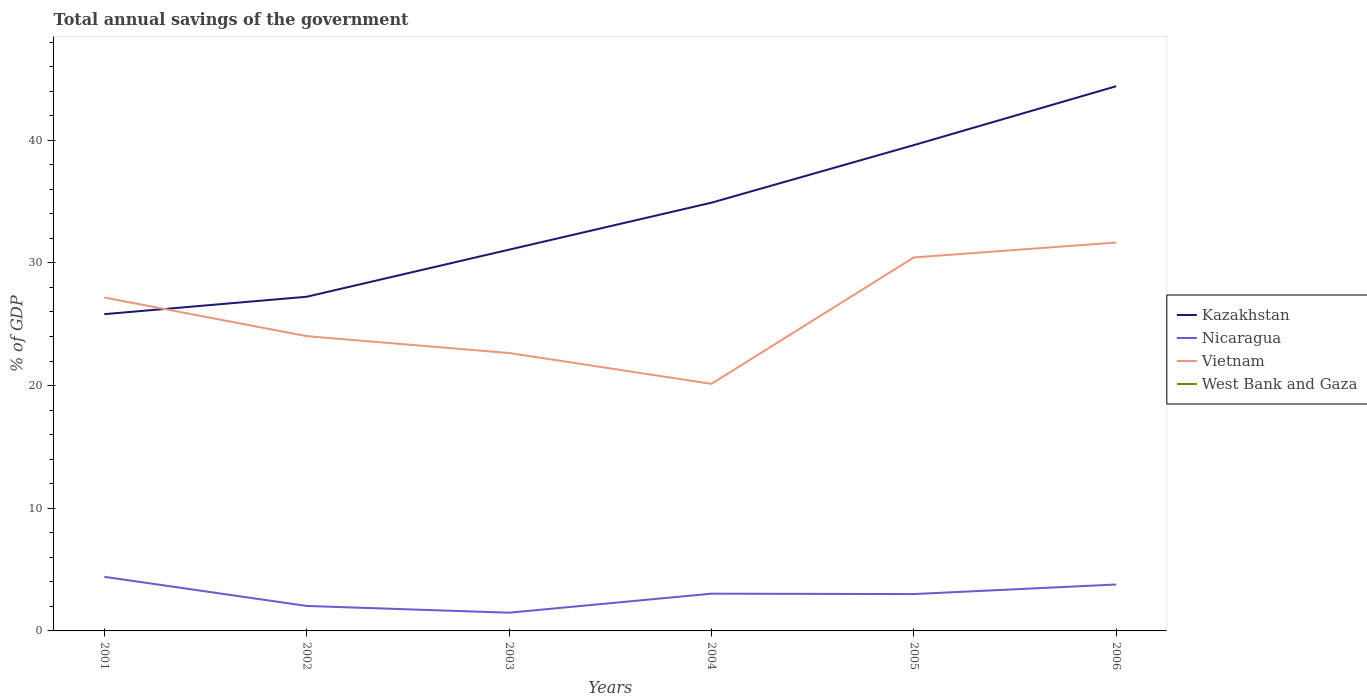Does the line corresponding to Nicaragua intersect with the line corresponding to Kazakhstan?
Provide a succinct answer. No. Is the number of lines equal to the number of legend labels?
Your answer should be very brief. No. Across all years, what is the maximum total annual savings of the government in Nicaragua?
Keep it short and to the point. 1.49. What is the total total annual savings of the government in Nicaragua in the graph?
Offer a very short reply. 0.55. What is the difference between the highest and the second highest total annual savings of the government in Nicaragua?
Your answer should be very brief. 2.93. What is the difference between the highest and the lowest total annual savings of the government in Vietnam?
Your answer should be very brief. 3. Is the total annual savings of the government in West Bank and Gaza strictly greater than the total annual savings of the government in Kazakhstan over the years?
Keep it short and to the point. Yes. How many lines are there?
Make the answer very short. 3. How many years are there in the graph?
Your answer should be very brief. 6. Does the graph contain grids?
Offer a very short reply. No. Where does the legend appear in the graph?
Make the answer very short. Center right. How many legend labels are there?
Provide a short and direct response. 4. How are the legend labels stacked?
Ensure brevity in your answer.  Vertical. What is the title of the graph?
Your response must be concise. Total annual savings of the government. Does "Korea (Republic)" appear as one of the legend labels in the graph?
Make the answer very short. No. What is the label or title of the Y-axis?
Keep it short and to the point. % of GDP. What is the % of GDP of Kazakhstan in 2001?
Offer a very short reply. 25.82. What is the % of GDP in Nicaragua in 2001?
Provide a succinct answer. 4.41. What is the % of GDP of Vietnam in 2001?
Keep it short and to the point. 27.17. What is the % of GDP of Kazakhstan in 2002?
Offer a very short reply. 27.24. What is the % of GDP of Nicaragua in 2002?
Provide a succinct answer. 2.04. What is the % of GDP in Vietnam in 2002?
Your response must be concise. 24.03. What is the % of GDP of Kazakhstan in 2003?
Provide a short and direct response. 31.07. What is the % of GDP in Nicaragua in 2003?
Provide a short and direct response. 1.49. What is the % of GDP of Vietnam in 2003?
Provide a short and direct response. 22.65. What is the % of GDP of West Bank and Gaza in 2003?
Provide a succinct answer. 0. What is the % of GDP in Kazakhstan in 2004?
Ensure brevity in your answer.  34.9. What is the % of GDP in Nicaragua in 2004?
Ensure brevity in your answer.  3.04. What is the % of GDP of Vietnam in 2004?
Ensure brevity in your answer.  20.14. What is the % of GDP in West Bank and Gaza in 2004?
Offer a very short reply. 0. What is the % of GDP in Kazakhstan in 2005?
Give a very brief answer. 39.6. What is the % of GDP of Nicaragua in 2005?
Provide a succinct answer. 3. What is the % of GDP of Vietnam in 2005?
Your response must be concise. 30.44. What is the % of GDP in West Bank and Gaza in 2005?
Provide a short and direct response. 0. What is the % of GDP in Kazakhstan in 2006?
Provide a succinct answer. 44.4. What is the % of GDP in Nicaragua in 2006?
Your response must be concise. 3.78. What is the % of GDP of Vietnam in 2006?
Provide a succinct answer. 31.66. Across all years, what is the maximum % of GDP in Kazakhstan?
Provide a succinct answer. 44.4. Across all years, what is the maximum % of GDP of Nicaragua?
Your answer should be very brief. 4.41. Across all years, what is the maximum % of GDP in Vietnam?
Ensure brevity in your answer.  31.66. Across all years, what is the minimum % of GDP in Kazakhstan?
Keep it short and to the point. 25.82. Across all years, what is the minimum % of GDP in Nicaragua?
Provide a short and direct response. 1.49. Across all years, what is the minimum % of GDP in Vietnam?
Your answer should be compact. 20.14. What is the total % of GDP in Kazakhstan in the graph?
Offer a terse response. 203.03. What is the total % of GDP of Nicaragua in the graph?
Provide a short and direct response. 17.75. What is the total % of GDP in Vietnam in the graph?
Ensure brevity in your answer.  156.09. What is the difference between the % of GDP in Kazakhstan in 2001 and that in 2002?
Your answer should be compact. -1.42. What is the difference between the % of GDP in Nicaragua in 2001 and that in 2002?
Ensure brevity in your answer.  2.38. What is the difference between the % of GDP in Vietnam in 2001 and that in 2002?
Offer a terse response. 3.15. What is the difference between the % of GDP in Kazakhstan in 2001 and that in 2003?
Your answer should be very brief. -5.26. What is the difference between the % of GDP in Nicaragua in 2001 and that in 2003?
Provide a succinct answer. 2.93. What is the difference between the % of GDP in Vietnam in 2001 and that in 2003?
Provide a succinct answer. 4.52. What is the difference between the % of GDP in Kazakhstan in 2001 and that in 2004?
Your answer should be compact. -9.09. What is the difference between the % of GDP of Nicaragua in 2001 and that in 2004?
Keep it short and to the point. 1.38. What is the difference between the % of GDP in Vietnam in 2001 and that in 2004?
Offer a terse response. 7.03. What is the difference between the % of GDP in Kazakhstan in 2001 and that in 2005?
Offer a very short reply. -13.78. What is the difference between the % of GDP in Nicaragua in 2001 and that in 2005?
Provide a short and direct response. 1.41. What is the difference between the % of GDP of Vietnam in 2001 and that in 2005?
Your answer should be very brief. -3.27. What is the difference between the % of GDP of Kazakhstan in 2001 and that in 2006?
Your response must be concise. -18.58. What is the difference between the % of GDP in Nicaragua in 2001 and that in 2006?
Your response must be concise. 0.63. What is the difference between the % of GDP in Vietnam in 2001 and that in 2006?
Your answer should be very brief. -4.48. What is the difference between the % of GDP in Kazakhstan in 2002 and that in 2003?
Offer a very short reply. -3.84. What is the difference between the % of GDP of Nicaragua in 2002 and that in 2003?
Make the answer very short. 0.55. What is the difference between the % of GDP in Vietnam in 2002 and that in 2003?
Your answer should be very brief. 1.37. What is the difference between the % of GDP of Kazakhstan in 2002 and that in 2004?
Provide a succinct answer. -7.67. What is the difference between the % of GDP of Nicaragua in 2002 and that in 2004?
Keep it short and to the point. -1. What is the difference between the % of GDP of Vietnam in 2002 and that in 2004?
Offer a very short reply. 3.89. What is the difference between the % of GDP of Kazakhstan in 2002 and that in 2005?
Ensure brevity in your answer.  -12.36. What is the difference between the % of GDP of Nicaragua in 2002 and that in 2005?
Provide a short and direct response. -0.97. What is the difference between the % of GDP in Vietnam in 2002 and that in 2005?
Keep it short and to the point. -6.42. What is the difference between the % of GDP in Kazakhstan in 2002 and that in 2006?
Ensure brevity in your answer.  -17.16. What is the difference between the % of GDP of Nicaragua in 2002 and that in 2006?
Offer a terse response. -1.75. What is the difference between the % of GDP of Vietnam in 2002 and that in 2006?
Keep it short and to the point. -7.63. What is the difference between the % of GDP of Kazakhstan in 2003 and that in 2004?
Provide a succinct answer. -3.83. What is the difference between the % of GDP in Nicaragua in 2003 and that in 2004?
Your response must be concise. -1.55. What is the difference between the % of GDP of Vietnam in 2003 and that in 2004?
Provide a succinct answer. 2.51. What is the difference between the % of GDP in Kazakhstan in 2003 and that in 2005?
Provide a short and direct response. -8.52. What is the difference between the % of GDP in Nicaragua in 2003 and that in 2005?
Your answer should be very brief. -1.52. What is the difference between the % of GDP in Vietnam in 2003 and that in 2005?
Provide a succinct answer. -7.79. What is the difference between the % of GDP of Kazakhstan in 2003 and that in 2006?
Ensure brevity in your answer.  -13.32. What is the difference between the % of GDP of Nicaragua in 2003 and that in 2006?
Your answer should be compact. -2.3. What is the difference between the % of GDP in Vietnam in 2003 and that in 2006?
Ensure brevity in your answer.  -9.01. What is the difference between the % of GDP of Kazakhstan in 2004 and that in 2005?
Your answer should be very brief. -4.69. What is the difference between the % of GDP of Nicaragua in 2004 and that in 2005?
Ensure brevity in your answer.  0.03. What is the difference between the % of GDP of Vietnam in 2004 and that in 2005?
Offer a very short reply. -10.3. What is the difference between the % of GDP of Kazakhstan in 2004 and that in 2006?
Offer a terse response. -9.5. What is the difference between the % of GDP in Nicaragua in 2004 and that in 2006?
Your answer should be very brief. -0.75. What is the difference between the % of GDP of Vietnam in 2004 and that in 2006?
Offer a very short reply. -11.52. What is the difference between the % of GDP in Kazakhstan in 2005 and that in 2006?
Provide a succinct answer. -4.8. What is the difference between the % of GDP in Nicaragua in 2005 and that in 2006?
Provide a succinct answer. -0.78. What is the difference between the % of GDP of Vietnam in 2005 and that in 2006?
Give a very brief answer. -1.22. What is the difference between the % of GDP in Kazakhstan in 2001 and the % of GDP in Nicaragua in 2002?
Offer a very short reply. 23.78. What is the difference between the % of GDP of Kazakhstan in 2001 and the % of GDP of Vietnam in 2002?
Your response must be concise. 1.79. What is the difference between the % of GDP in Nicaragua in 2001 and the % of GDP in Vietnam in 2002?
Offer a terse response. -19.62. What is the difference between the % of GDP of Kazakhstan in 2001 and the % of GDP of Nicaragua in 2003?
Your answer should be very brief. 24.33. What is the difference between the % of GDP in Kazakhstan in 2001 and the % of GDP in Vietnam in 2003?
Provide a short and direct response. 3.17. What is the difference between the % of GDP in Nicaragua in 2001 and the % of GDP in Vietnam in 2003?
Your response must be concise. -18.24. What is the difference between the % of GDP in Kazakhstan in 2001 and the % of GDP in Nicaragua in 2004?
Offer a very short reply. 22.78. What is the difference between the % of GDP in Kazakhstan in 2001 and the % of GDP in Vietnam in 2004?
Your answer should be very brief. 5.68. What is the difference between the % of GDP in Nicaragua in 2001 and the % of GDP in Vietnam in 2004?
Provide a short and direct response. -15.73. What is the difference between the % of GDP of Kazakhstan in 2001 and the % of GDP of Nicaragua in 2005?
Keep it short and to the point. 22.81. What is the difference between the % of GDP of Kazakhstan in 2001 and the % of GDP of Vietnam in 2005?
Your answer should be very brief. -4.62. What is the difference between the % of GDP of Nicaragua in 2001 and the % of GDP of Vietnam in 2005?
Keep it short and to the point. -26.03. What is the difference between the % of GDP in Kazakhstan in 2001 and the % of GDP in Nicaragua in 2006?
Give a very brief answer. 22.03. What is the difference between the % of GDP of Kazakhstan in 2001 and the % of GDP of Vietnam in 2006?
Your response must be concise. -5.84. What is the difference between the % of GDP in Nicaragua in 2001 and the % of GDP in Vietnam in 2006?
Offer a very short reply. -27.25. What is the difference between the % of GDP of Kazakhstan in 2002 and the % of GDP of Nicaragua in 2003?
Offer a very short reply. 25.75. What is the difference between the % of GDP in Kazakhstan in 2002 and the % of GDP in Vietnam in 2003?
Your response must be concise. 4.59. What is the difference between the % of GDP of Nicaragua in 2002 and the % of GDP of Vietnam in 2003?
Offer a very short reply. -20.62. What is the difference between the % of GDP of Kazakhstan in 2002 and the % of GDP of Nicaragua in 2004?
Make the answer very short. 24.2. What is the difference between the % of GDP of Kazakhstan in 2002 and the % of GDP of Vietnam in 2004?
Provide a succinct answer. 7.1. What is the difference between the % of GDP of Nicaragua in 2002 and the % of GDP of Vietnam in 2004?
Provide a short and direct response. -18.1. What is the difference between the % of GDP in Kazakhstan in 2002 and the % of GDP in Nicaragua in 2005?
Offer a terse response. 24.23. What is the difference between the % of GDP of Kazakhstan in 2002 and the % of GDP of Vietnam in 2005?
Keep it short and to the point. -3.2. What is the difference between the % of GDP of Nicaragua in 2002 and the % of GDP of Vietnam in 2005?
Offer a very short reply. -28.41. What is the difference between the % of GDP in Kazakhstan in 2002 and the % of GDP in Nicaragua in 2006?
Offer a very short reply. 23.45. What is the difference between the % of GDP of Kazakhstan in 2002 and the % of GDP of Vietnam in 2006?
Your answer should be compact. -4.42. What is the difference between the % of GDP in Nicaragua in 2002 and the % of GDP in Vietnam in 2006?
Your answer should be very brief. -29.62. What is the difference between the % of GDP in Kazakhstan in 2003 and the % of GDP in Nicaragua in 2004?
Give a very brief answer. 28.04. What is the difference between the % of GDP of Kazakhstan in 2003 and the % of GDP of Vietnam in 2004?
Your response must be concise. 10.94. What is the difference between the % of GDP of Nicaragua in 2003 and the % of GDP of Vietnam in 2004?
Offer a very short reply. -18.65. What is the difference between the % of GDP in Kazakhstan in 2003 and the % of GDP in Nicaragua in 2005?
Give a very brief answer. 28.07. What is the difference between the % of GDP in Kazakhstan in 2003 and the % of GDP in Vietnam in 2005?
Provide a short and direct response. 0.63. What is the difference between the % of GDP of Nicaragua in 2003 and the % of GDP of Vietnam in 2005?
Give a very brief answer. -28.96. What is the difference between the % of GDP in Kazakhstan in 2003 and the % of GDP in Nicaragua in 2006?
Ensure brevity in your answer.  27.29. What is the difference between the % of GDP in Kazakhstan in 2003 and the % of GDP in Vietnam in 2006?
Offer a very short reply. -0.58. What is the difference between the % of GDP of Nicaragua in 2003 and the % of GDP of Vietnam in 2006?
Provide a succinct answer. -30.17. What is the difference between the % of GDP in Kazakhstan in 2004 and the % of GDP in Nicaragua in 2005?
Ensure brevity in your answer.  31.9. What is the difference between the % of GDP of Kazakhstan in 2004 and the % of GDP of Vietnam in 2005?
Ensure brevity in your answer.  4.46. What is the difference between the % of GDP in Nicaragua in 2004 and the % of GDP in Vietnam in 2005?
Give a very brief answer. -27.41. What is the difference between the % of GDP in Kazakhstan in 2004 and the % of GDP in Nicaragua in 2006?
Provide a succinct answer. 31.12. What is the difference between the % of GDP in Kazakhstan in 2004 and the % of GDP in Vietnam in 2006?
Make the answer very short. 3.25. What is the difference between the % of GDP in Nicaragua in 2004 and the % of GDP in Vietnam in 2006?
Provide a succinct answer. -28.62. What is the difference between the % of GDP in Kazakhstan in 2005 and the % of GDP in Nicaragua in 2006?
Your response must be concise. 35.81. What is the difference between the % of GDP of Kazakhstan in 2005 and the % of GDP of Vietnam in 2006?
Offer a very short reply. 7.94. What is the difference between the % of GDP of Nicaragua in 2005 and the % of GDP of Vietnam in 2006?
Keep it short and to the point. -28.65. What is the average % of GDP in Kazakhstan per year?
Ensure brevity in your answer.  33.84. What is the average % of GDP in Nicaragua per year?
Provide a short and direct response. 2.96. What is the average % of GDP in Vietnam per year?
Make the answer very short. 26.01. What is the average % of GDP in West Bank and Gaza per year?
Keep it short and to the point. 0. In the year 2001, what is the difference between the % of GDP in Kazakhstan and % of GDP in Nicaragua?
Give a very brief answer. 21.41. In the year 2001, what is the difference between the % of GDP in Kazakhstan and % of GDP in Vietnam?
Offer a very short reply. -1.36. In the year 2001, what is the difference between the % of GDP in Nicaragua and % of GDP in Vietnam?
Your answer should be very brief. -22.76. In the year 2002, what is the difference between the % of GDP of Kazakhstan and % of GDP of Nicaragua?
Your response must be concise. 25.2. In the year 2002, what is the difference between the % of GDP in Kazakhstan and % of GDP in Vietnam?
Your response must be concise. 3.21. In the year 2002, what is the difference between the % of GDP of Nicaragua and % of GDP of Vietnam?
Give a very brief answer. -21.99. In the year 2003, what is the difference between the % of GDP of Kazakhstan and % of GDP of Nicaragua?
Provide a succinct answer. 29.59. In the year 2003, what is the difference between the % of GDP of Kazakhstan and % of GDP of Vietnam?
Make the answer very short. 8.42. In the year 2003, what is the difference between the % of GDP of Nicaragua and % of GDP of Vietnam?
Offer a terse response. -21.17. In the year 2004, what is the difference between the % of GDP in Kazakhstan and % of GDP in Nicaragua?
Provide a succinct answer. 31.87. In the year 2004, what is the difference between the % of GDP in Kazakhstan and % of GDP in Vietnam?
Keep it short and to the point. 14.76. In the year 2004, what is the difference between the % of GDP of Nicaragua and % of GDP of Vietnam?
Offer a very short reply. -17.1. In the year 2005, what is the difference between the % of GDP of Kazakhstan and % of GDP of Nicaragua?
Provide a succinct answer. 36.59. In the year 2005, what is the difference between the % of GDP of Kazakhstan and % of GDP of Vietnam?
Your answer should be very brief. 9.15. In the year 2005, what is the difference between the % of GDP of Nicaragua and % of GDP of Vietnam?
Provide a short and direct response. -27.44. In the year 2006, what is the difference between the % of GDP of Kazakhstan and % of GDP of Nicaragua?
Your answer should be very brief. 40.61. In the year 2006, what is the difference between the % of GDP in Kazakhstan and % of GDP in Vietnam?
Provide a succinct answer. 12.74. In the year 2006, what is the difference between the % of GDP of Nicaragua and % of GDP of Vietnam?
Offer a terse response. -27.87. What is the ratio of the % of GDP in Kazakhstan in 2001 to that in 2002?
Give a very brief answer. 0.95. What is the ratio of the % of GDP of Nicaragua in 2001 to that in 2002?
Your answer should be very brief. 2.17. What is the ratio of the % of GDP of Vietnam in 2001 to that in 2002?
Give a very brief answer. 1.13. What is the ratio of the % of GDP of Kazakhstan in 2001 to that in 2003?
Offer a very short reply. 0.83. What is the ratio of the % of GDP in Nicaragua in 2001 to that in 2003?
Your response must be concise. 2.97. What is the ratio of the % of GDP in Vietnam in 2001 to that in 2003?
Offer a very short reply. 1.2. What is the ratio of the % of GDP in Kazakhstan in 2001 to that in 2004?
Provide a short and direct response. 0.74. What is the ratio of the % of GDP of Nicaragua in 2001 to that in 2004?
Your response must be concise. 1.45. What is the ratio of the % of GDP of Vietnam in 2001 to that in 2004?
Offer a very short reply. 1.35. What is the ratio of the % of GDP in Kazakhstan in 2001 to that in 2005?
Your answer should be compact. 0.65. What is the ratio of the % of GDP in Nicaragua in 2001 to that in 2005?
Give a very brief answer. 1.47. What is the ratio of the % of GDP in Vietnam in 2001 to that in 2005?
Provide a succinct answer. 0.89. What is the ratio of the % of GDP of Kazakhstan in 2001 to that in 2006?
Your answer should be compact. 0.58. What is the ratio of the % of GDP in Nicaragua in 2001 to that in 2006?
Your response must be concise. 1.17. What is the ratio of the % of GDP of Vietnam in 2001 to that in 2006?
Offer a very short reply. 0.86. What is the ratio of the % of GDP in Kazakhstan in 2002 to that in 2003?
Offer a terse response. 0.88. What is the ratio of the % of GDP in Nicaragua in 2002 to that in 2003?
Give a very brief answer. 1.37. What is the ratio of the % of GDP in Vietnam in 2002 to that in 2003?
Your response must be concise. 1.06. What is the ratio of the % of GDP in Kazakhstan in 2002 to that in 2004?
Your answer should be compact. 0.78. What is the ratio of the % of GDP in Nicaragua in 2002 to that in 2004?
Your answer should be very brief. 0.67. What is the ratio of the % of GDP in Vietnam in 2002 to that in 2004?
Your response must be concise. 1.19. What is the ratio of the % of GDP of Kazakhstan in 2002 to that in 2005?
Your answer should be compact. 0.69. What is the ratio of the % of GDP in Nicaragua in 2002 to that in 2005?
Your response must be concise. 0.68. What is the ratio of the % of GDP of Vietnam in 2002 to that in 2005?
Offer a terse response. 0.79. What is the ratio of the % of GDP in Kazakhstan in 2002 to that in 2006?
Provide a short and direct response. 0.61. What is the ratio of the % of GDP of Nicaragua in 2002 to that in 2006?
Offer a terse response. 0.54. What is the ratio of the % of GDP in Vietnam in 2002 to that in 2006?
Your answer should be very brief. 0.76. What is the ratio of the % of GDP in Kazakhstan in 2003 to that in 2004?
Provide a succinct answer. 0.89. What is the ratio of the % of GDP of Nicaragua in 2003 to that in 2004?
Your response must be concise. 0.49. What is the ratio of the % of GDP of Vietnam in 2003 to that in 2004?
Provide a short and direct response. 1.12. What is the ratio of the % of GDP in Kazakhstan in 2003 to that in 2005?
Provide a short and direct response. 0.78. What is the ratio of the % of GDP of Nicaragua in 2003 to that in 2005?
Give a very brief answer. 0.49. What is the ratio of the % of GDP of Vietnam in 2003 to that in 2005?
Your answer should be compact. 0.74. What is the ratio of the % of GDP of Kazakhstan in 2003 to that in 2006?
Give a very brief answer. 0.7. What is the ratio of the % of GDP in Nicaragua in 2003 to that in 2006?
Your answer should be compact. 0.39. What is the ratio of the % of GDP in Vietnam in 2003 to that in 2006?
Your answer should be very brief. 0.72. What is the ratio of the % of GDP in Kazakhstan in 2004 to that in 2005?
Keep it short and to the point. 0.88. What is the ratio of the % of GDP of Nicaragua in 2004 to that in 2005?
Your answer should be very brief. 1.01. What is the ratio of the % of GDP of Vietnam in 2004 to that in 2005?
Offer a terse response. 0.66. What is the ratio of the % of GDP of Kazakhstan in 2004 to that in 2006?
Your response must be concise. 0.79. What is the ratio of the % of GDP of Nicaragua in 2004 to that in 2006?
Provide a succinct answer. 0.8. What is the ratio of the % of GDP of Vietnam in 2004 to that in 2006?
Your response must be concise. 0.64. What is the ratio of the % of GDP of Kazakhstan in 2005 to that in 2006?
Provide a succinct answer. 0.89. What is the ratio of the % of GDP of Nicaragua in 2005 to that in 2006?
Your response must be concise. 0.79. What is the ratio of the % of GDP in Vietnam in 2005 to that in 2006?
Your response must be concise. 0.96. What is the difference between the highest and the second highest % of GDP in Kazakhstan?
Your response must be concise. 4.8. What is the difference between the highest and the second highest % of GDP of Nicaragua?
Keep it short and to the point. 0.63. What is the difference between the highest and the second highest % of GDP in Vietnam?
Make the answer very short. 1.22. What is the difference between the highest and the lowest % of GDP in Kazakhstan?
Make the answer very short. 18.58. What is the difference between the highest and the lowest % of GDP of Nicaragua?
Your answer should be compact. 2.93. What is the difference between the highest and the lowest % of GDP of Vietnam?
Your answer should be compact. 11.52. 